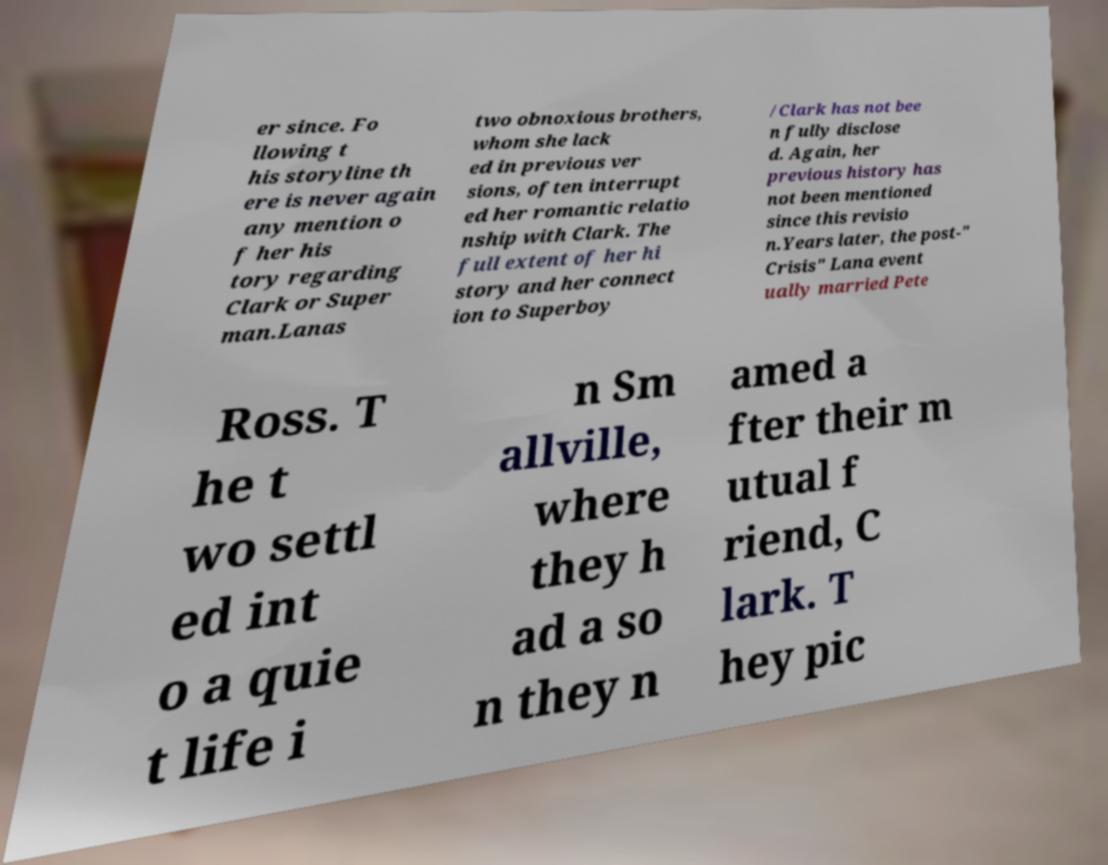What messages or text are displayed in this image? I need them in a readable, typed format. er since. Fo llowing t his storyline th ere is never again any mention o f her his tory regarding Clark or Super man.Lanas two obnoxious brothers, whom she lack ed in previous ver sions, often interrupt ed her romantic relatio nship with Clark. The full extent of her hi story and her connect ion to Superboy /Clark has not bee n fully disclose d. Again, her previous history has not been mentioned since this revisio n.Years later, the post-" Crisis" Lana event ually married Pete Ross. T he t wo settl ed int o a quie t life i n Sm allville, where they h ad a so n they n amed a fter their m utual f riend, C lark. T hey pic 